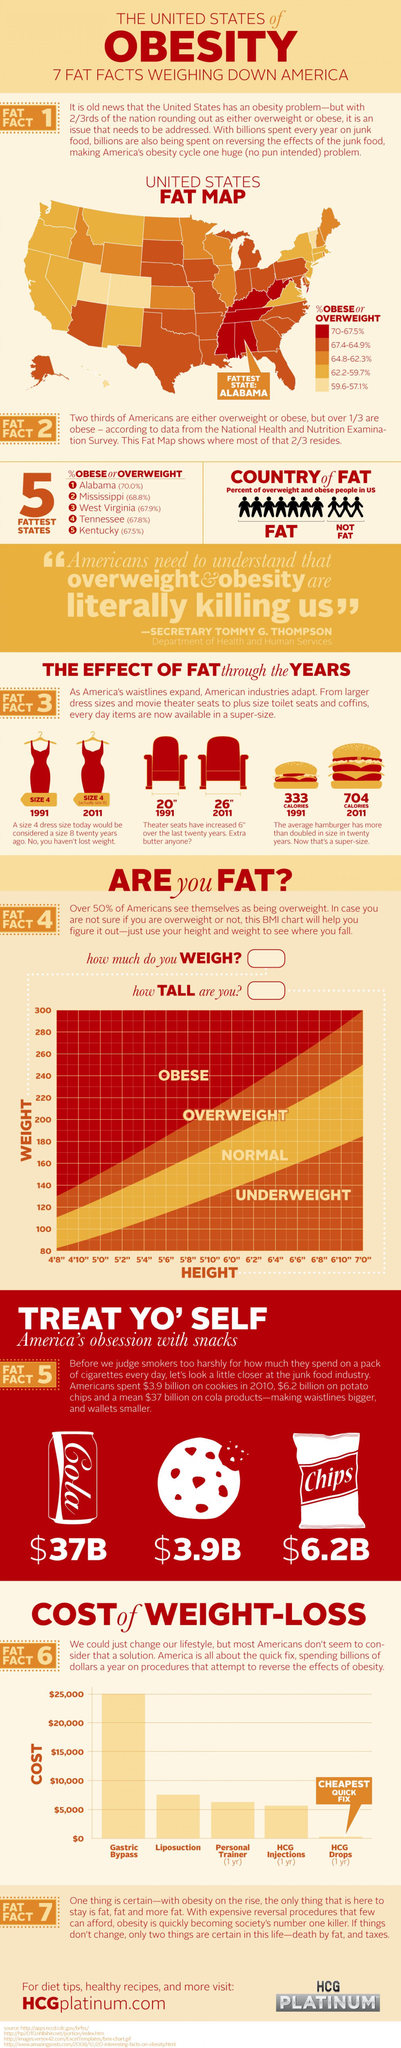What percentage of people in Alabama are not obese?
Answer the question with a short phrase. 30% What percentage of people in Mississippi are obese? 68.8% Which is the considered as the fattest state in U.S.? ALABAMA What percentage of people in West Virginia are obese? 67.9% Which state in U.S. has the least no of obese people? Kentucky 